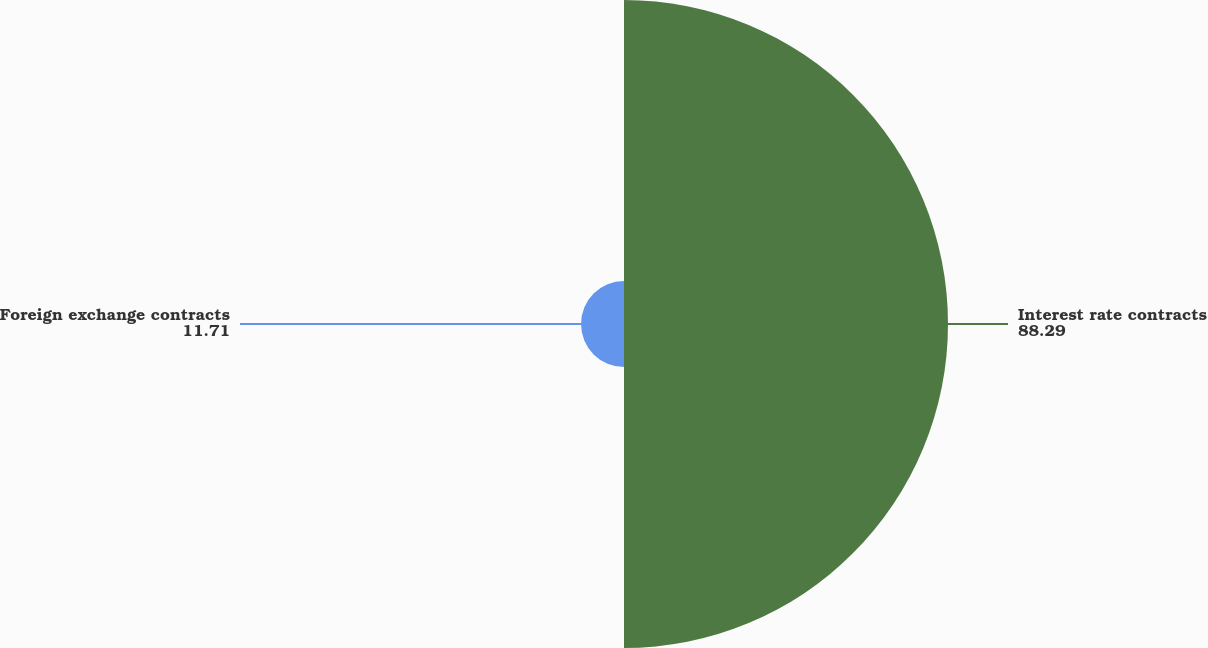Convert chart to OTSL. <chart><loc_0><loc_0><loc_500><loc_500><pie_chart><fcel>Interest rate contracts<fcel>Foreign exchange contracts<nl><fcel>88.29%<fcel>11.71%<nl></chart> 